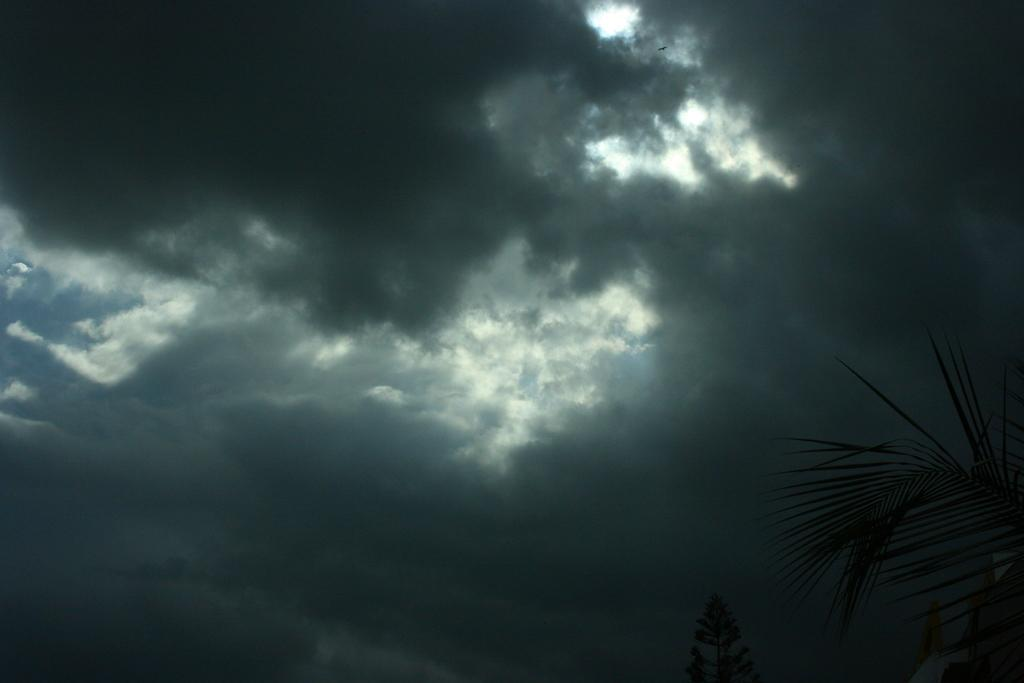What type of vegetation can be seen in the image? There are trees in the image. What is visible in the background of the image? The sky is visible in the background of the image. What can be observed in the sky? Clouds are present in the sky. What type of vest can be seen hanging from the trees in the image? There is no vest present in the image; it features trees and a sky with clouds. 